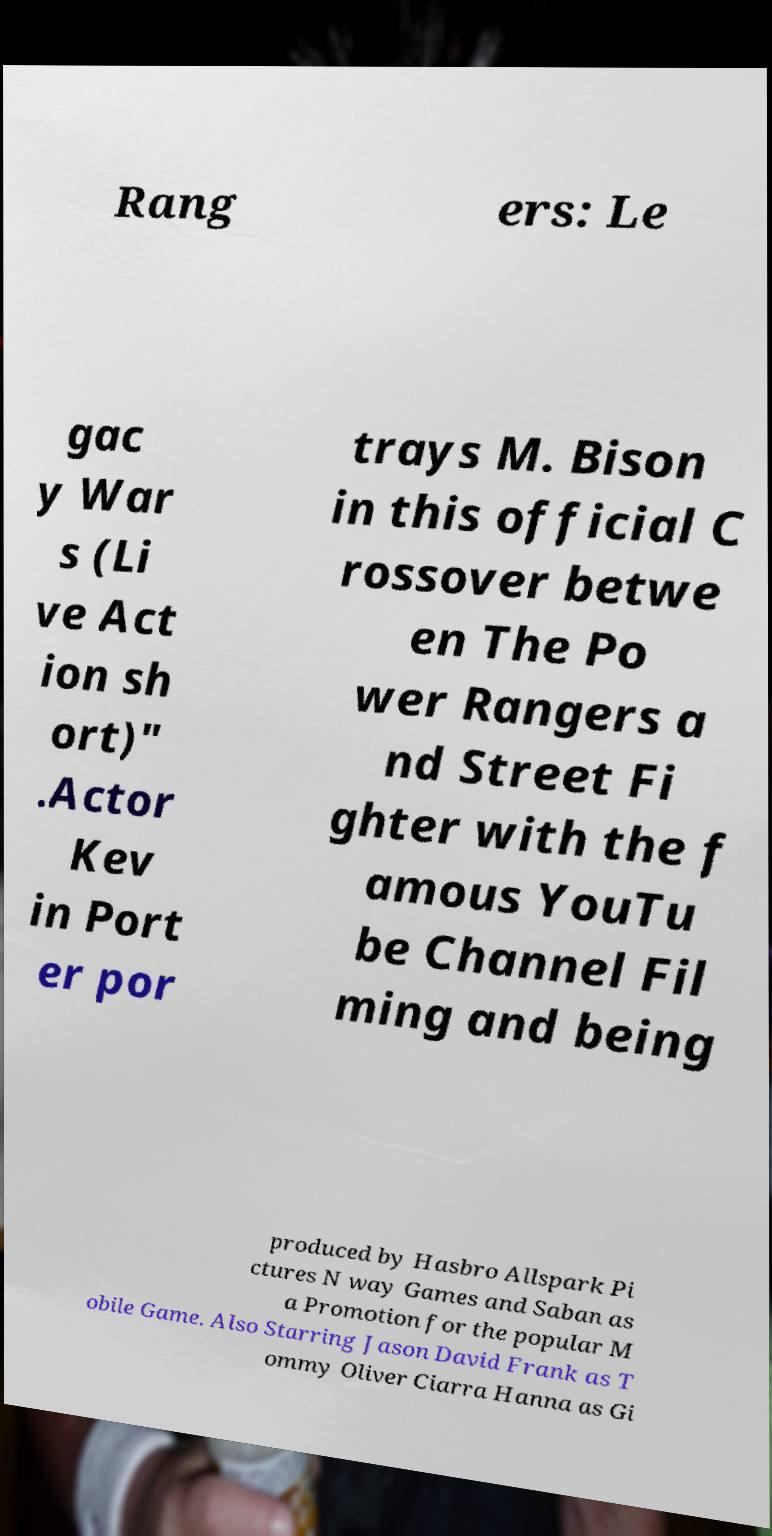What messages or text are displayed in this image? I need them in a readable, typed format. Rang ers: Le gac y War s (Li ve Act ion sh ort)" .Actor Kev in Port er por trays M. Bison in this official C rossover betwe en The Po wer Rangers a nd Street Fi ghter with the f amous YouTu be Channel Fil ming and being produced by Hasbro Allspark Pi ctures N way Games and Saban as a Promotion for the popular M obile Game. Also Starring Jason David Frank as T ommy Oliver Ciarra Hanna as Gi 